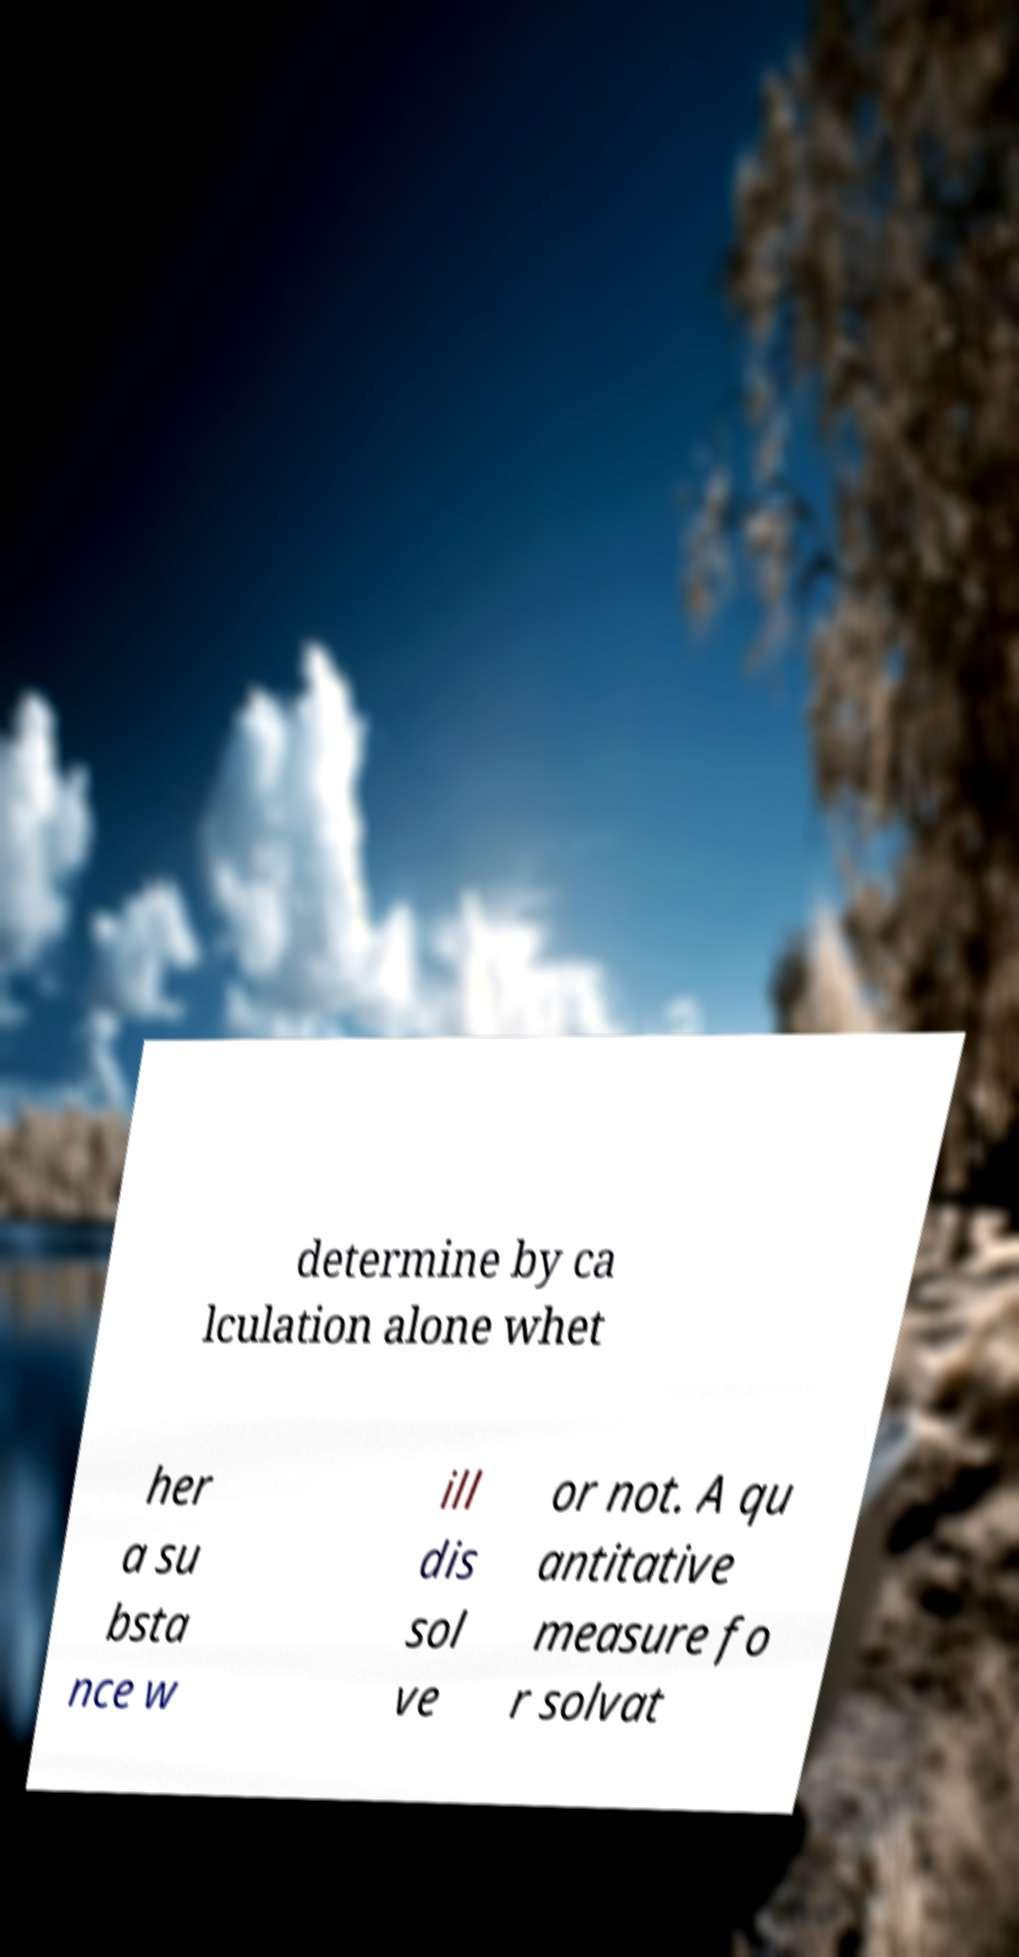Could you assist in decoding the text presented in this image and type it out clearly? determine by ca lculation alone whet her a su bsta nce w ill dis sol ve or not. A qu antitative measure fo r solvat 